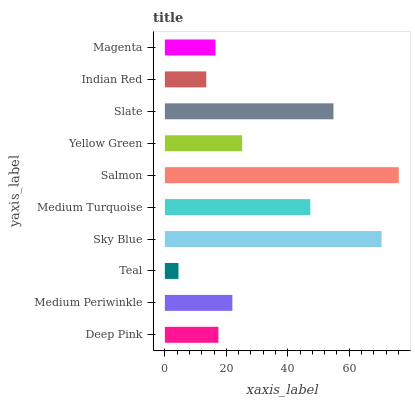Is Teal the minimum?
Answer yes or no. Yes. Is Salmon the maximum?
Answer yes or no. Yes. Is Medium Periwinkle the minimum?
Answer yes or no. No. Is Medium Periwinkle the maximum?
Answer yes or no. No. Is Medium Periwinkle greater than Deep Pink?
Answer yes or no. Yes. Is Deep Pink less than Medium Periwinkle?
Answer yes or no. Yes. Is Deep Pink greater than Medium Periwinkle?
Answer yes or no. No. Is Medium Periwinkle less than Deep Pink?
Answer yes or no. No. Is Yellow Green the high median?
Answer yes or no. Yes. Is Medium Periwinkle the low median?
Answer yes or no. Yes. Is Medium Periwinkle the high median?
Answer yes or no. No. Is Deep Pink the low median?
Answer yes or no. No. 